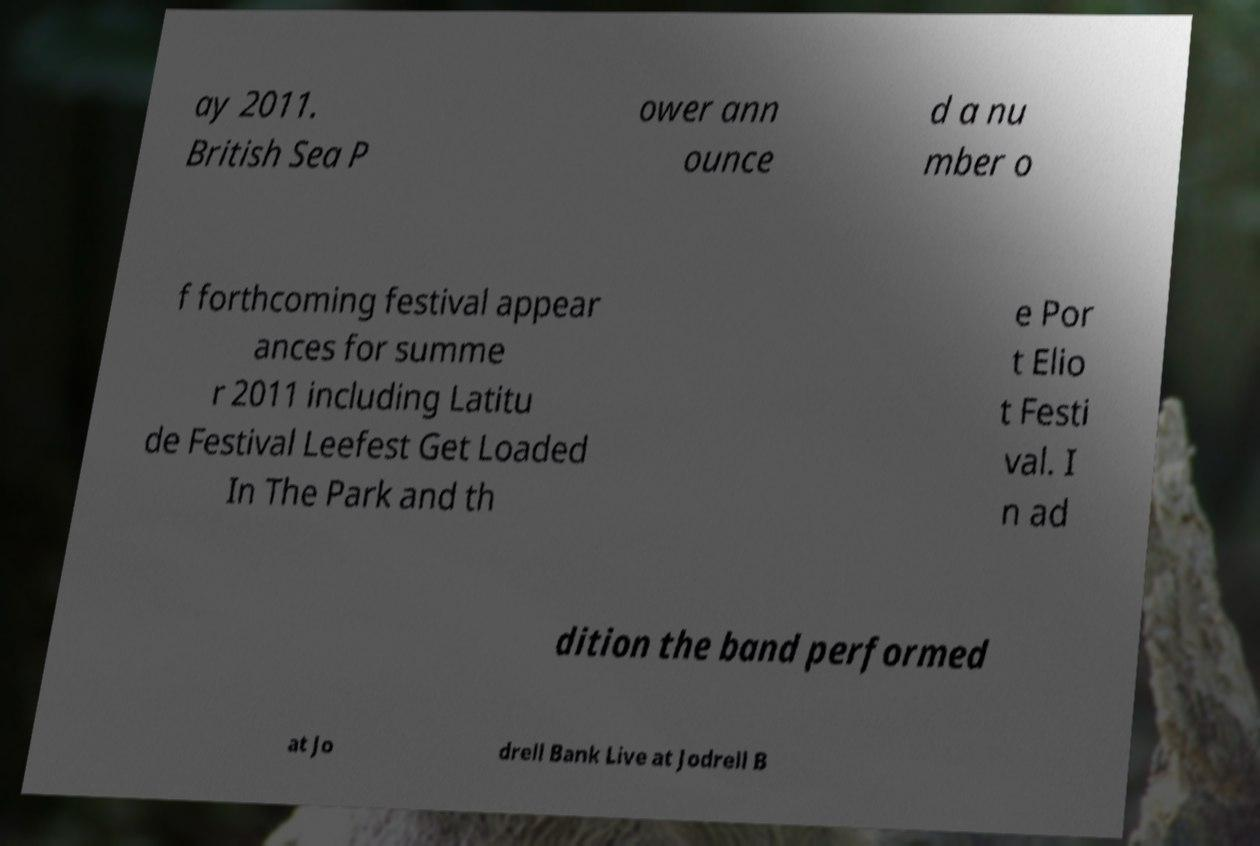Could you assist in decoding the text presented in this image and type it out clearly? ay 2011. British Sea P ower ann ounce d a nu mber o f forthcoming festival appear ances for summe r 2011 including Latitu de Festival Leefest Get Loaded In The Park and th e Por t Elio t Festi val. I n ad dition the band performed at Jo drell Bank Live at Jodrell B 